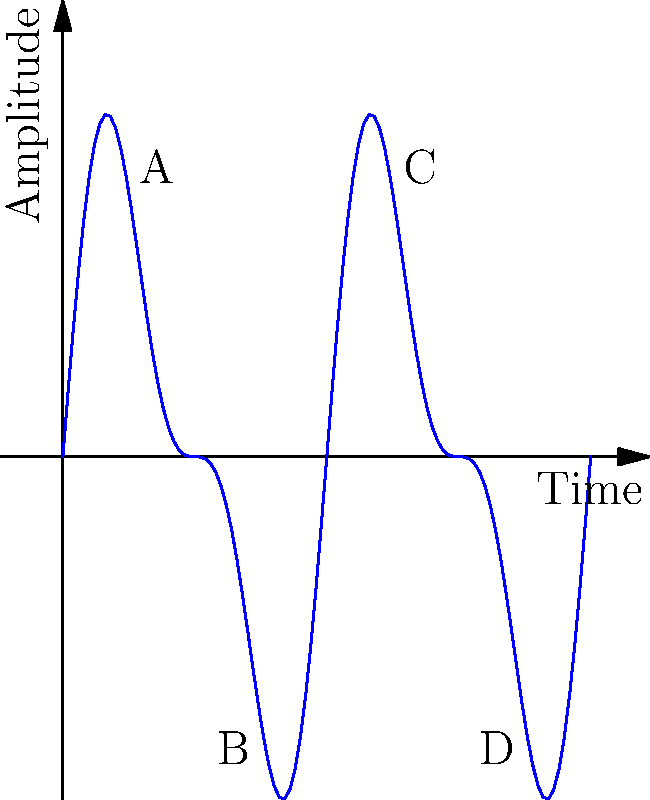In the context of vinyl record grooves, which point on this waveform represents the deepest part of the groove, corresponding to the loudest part of the sound? To answer this question, we need to understand the relationship between sound waves and vinyl record grooves:

1. Vinyl record grooves are physical representations of sound waves.
2. The depth of the groove corresponds to the amplitude of the sound wave.
3. Higher amplitude (larger distance from the center line) represents louder sounds.
4. The deepest part of the groove corresponds to the point furthest from the center line (x-axis in this case).

Analyzing the waveform:

1. Point A is at a local maximum, but not the highest point.
2. Point B is at a local minimum, but not the lowest point.
3. Point C is the highest point on the waveform, furthest above the x-axis.
4. Point D is the lowest point on the waveform, furthest below the x-axis.

The deepest part of the groove can be either the highest peak or the lowest trough, as both represent the maximum amplitude. In this case, point C has a slightly larger absolute amplitude than point D.

Therefore, point C represents the deepest part of the groove and the loudest part of the sound.
Answer: C 